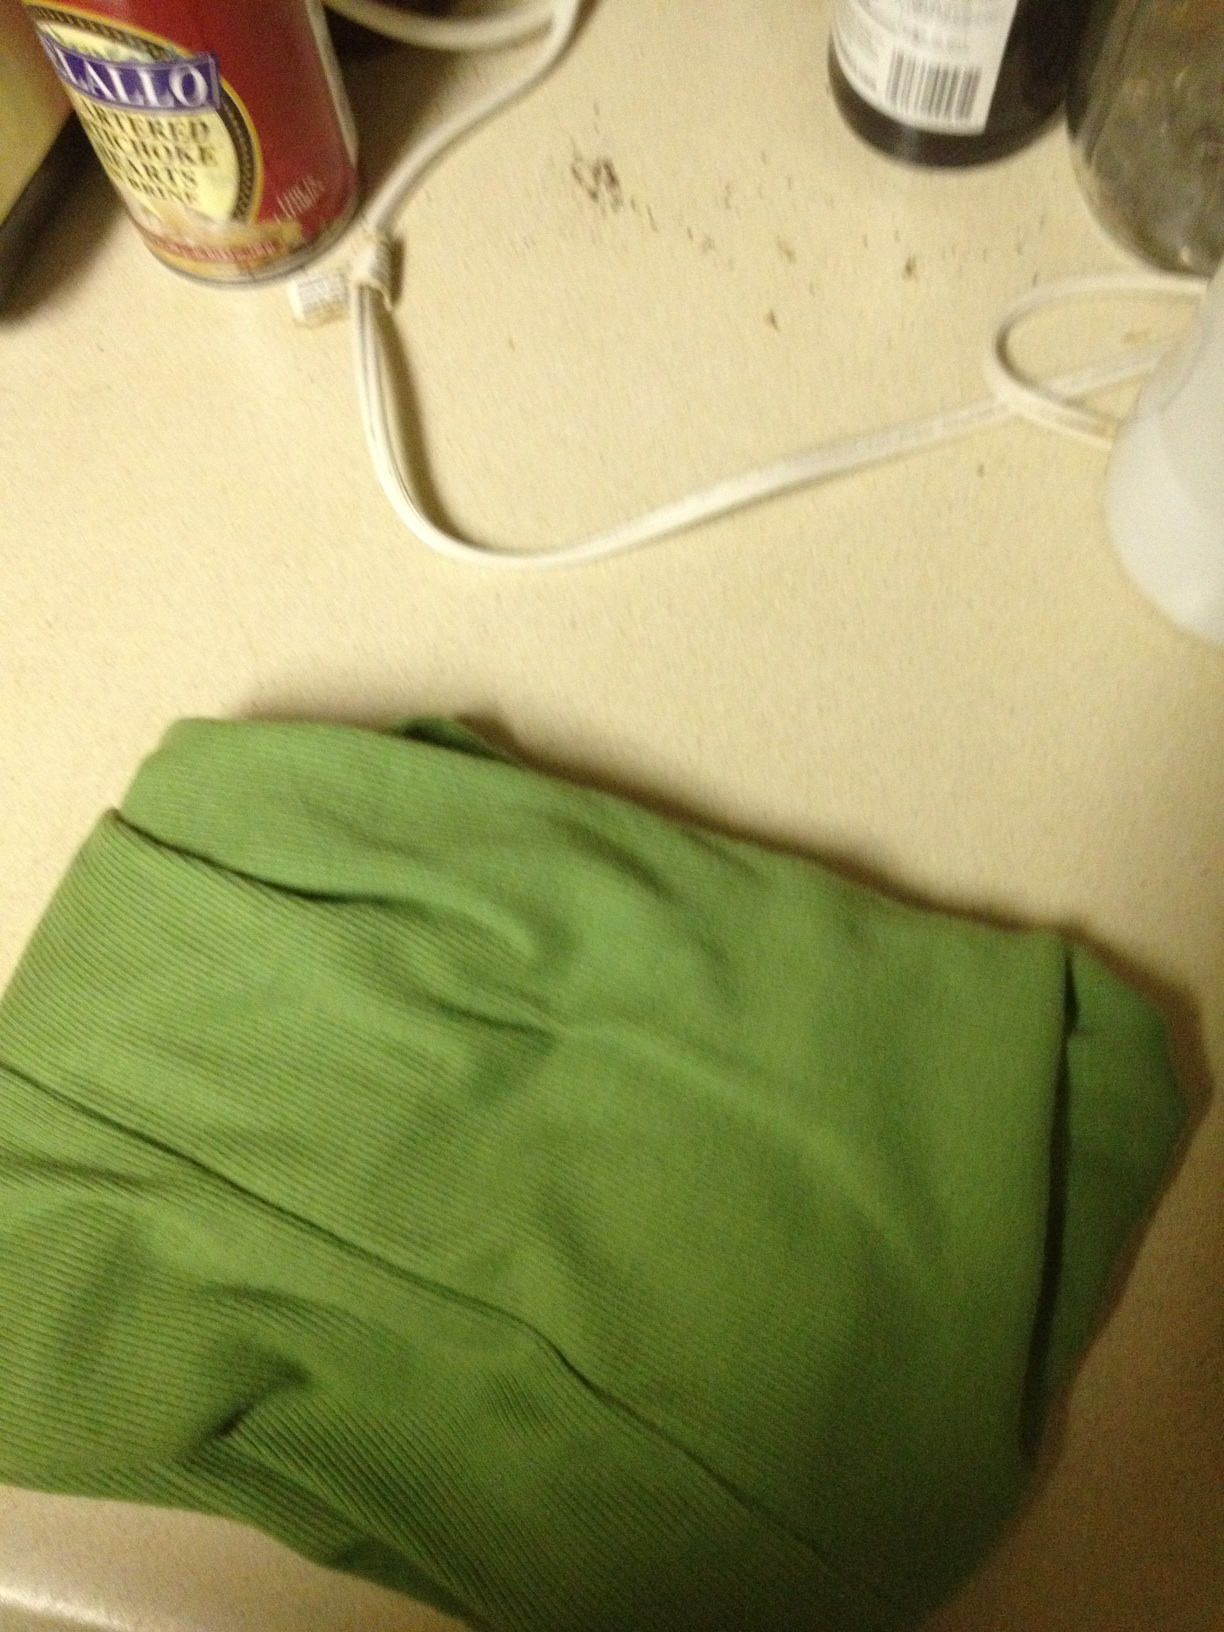Imagine if this shirt could talk, what would it say about where it came from? If the shirt could talk, it might say: 'I was once a cotton plant, growing under the warm sun and gentle rains. After being harvested and processed, I was woven into fabric and dyed this lovely shade of green. Soon after, I was fashioned into a comfortable shirt, ready to bring a touch of color to someone’s wardrobe.' How would you describe the ambiance or mood of the image based on the elements present? The image presents a somewhat utilitarian ambiance, with a mix of casualness introduced by the green shirt, and the everyday household items like the can and bottle. The presence of the electrical cord and other bits suggest a practical, lived-in space, giving a sense of familiarity and domesticity. Describe a creative story where this green shirt is the protagonist. Once upon a time, in a bustling household, there was a green shirt named Clover. Clover was not just any shirt; it had the magical ability to change colors based on the wearer’s mood. One day, Clover found itself in the hands of a young artist named Emily. As Emily wore Clover, it turned a brilliant shade of yellow, reflecting her joy and creativity. Together, they explored various art forms, from painting to sculpting, with Clover providing endless inspiration. Emily soon discovered that whenever she struggled with a creative block, Clover's colors would guide her emotions and unlock new ideas. Clover became her muse, changing colors to red when she needed passion, blue for calm, and every hue in between to spark new sensations. Their journey together was a vibrant tapestry of color, creativity, and boundless imagination, with Clover always at the heart of Emily’s artistic adventures. 